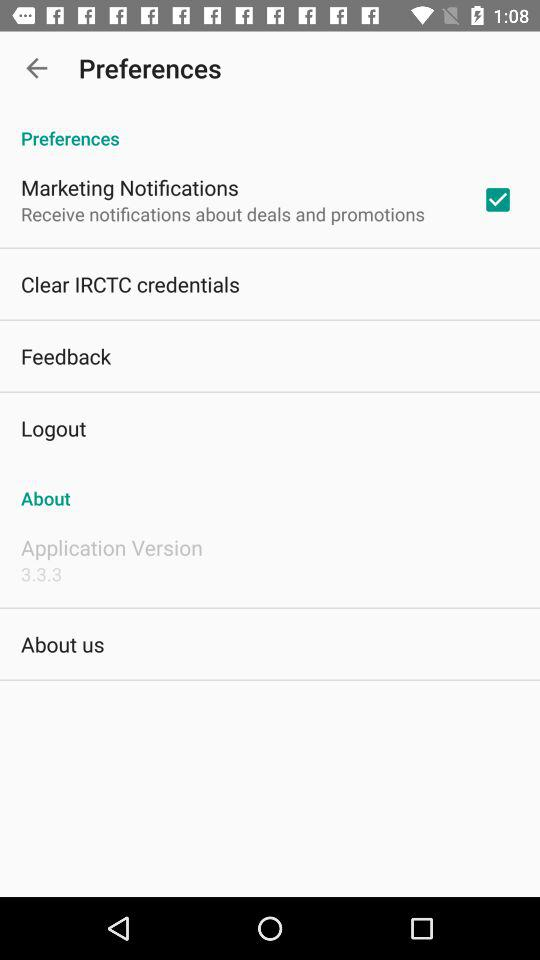What is the status of the "Marketing Notifications"? The status of the "Marketing Notifications" is "on". 